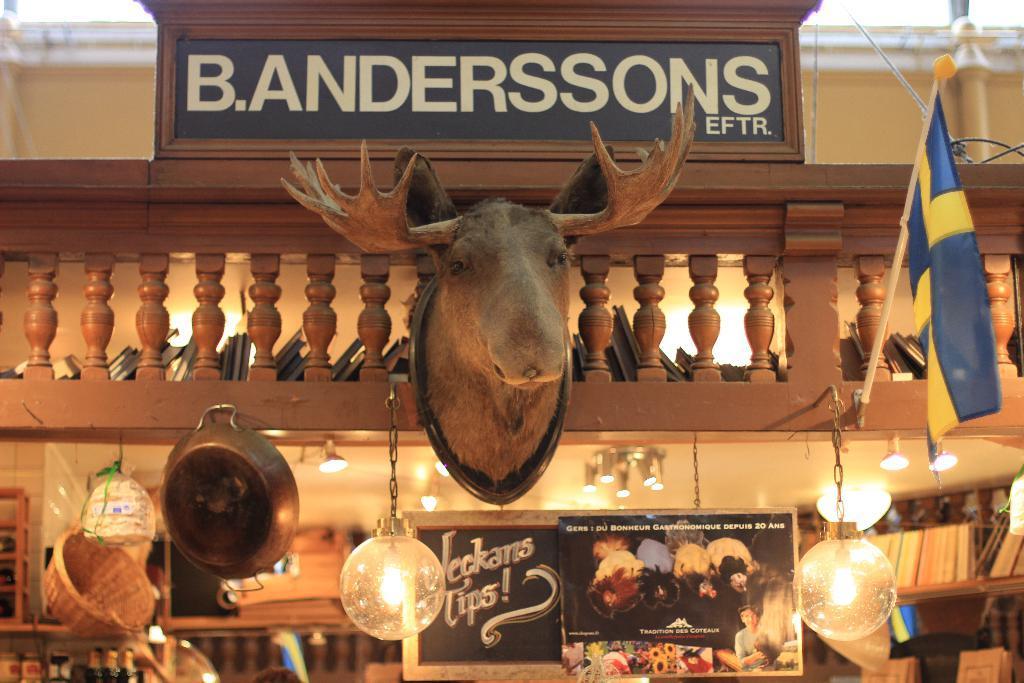How would you summarize this image in a sentence or two? In the picture I can see animal stuffed face is hanged to the wall, we can see ceiling lights, a board, few objects and a board on which we can see some text is written. 